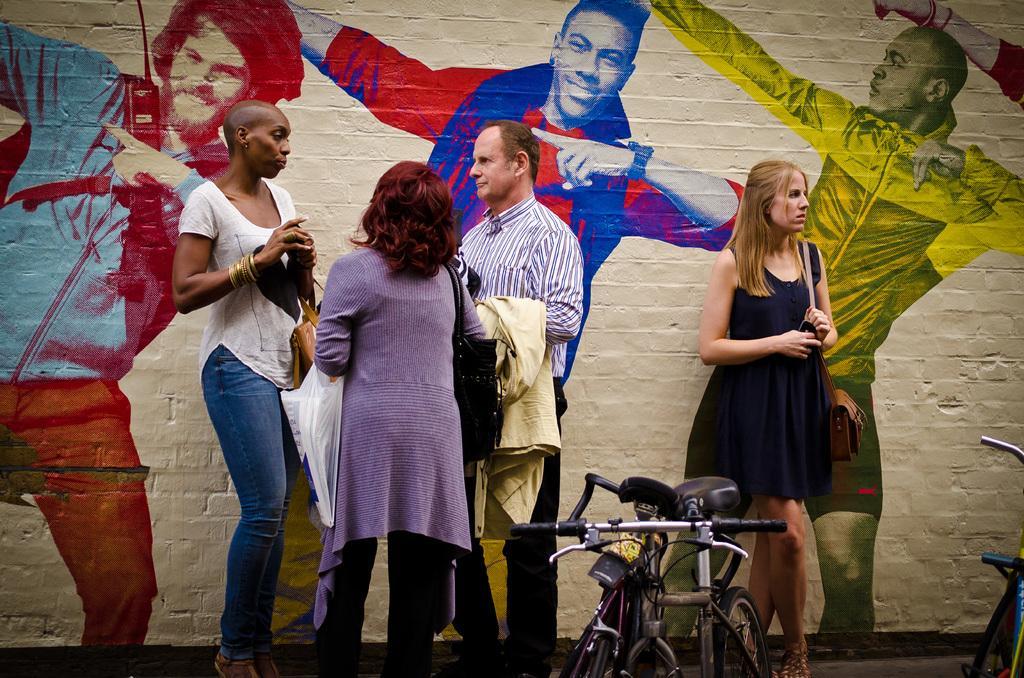In one or two sentences, can you explain what this image depicts? In the foreground of the picture there are people and bicycles. In the background there is a wall, painted with human figures. 